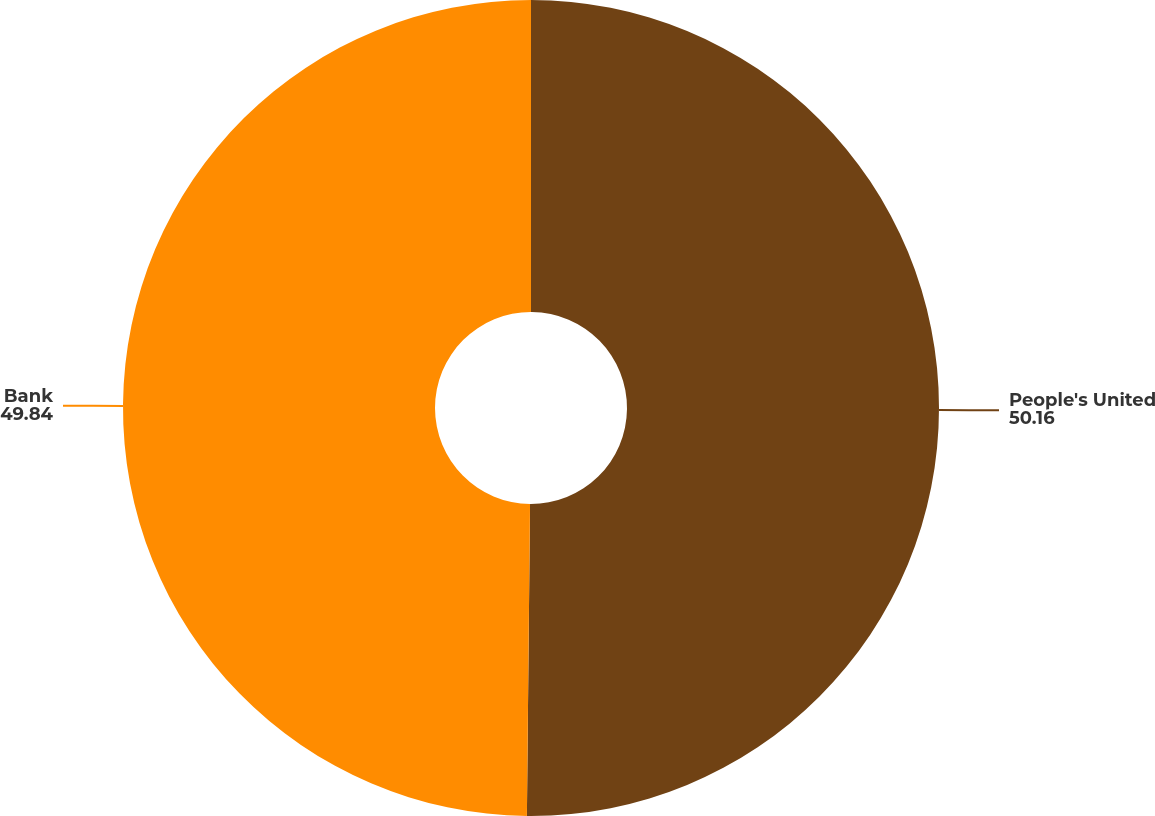Convert chart. <chart><loc_0><loc_0><loc_500><loc_500><pie_chart><fcel>People's United<fcel>Bank<nl><fcel>50.16%<fcel>49.84%<nl></chart> 